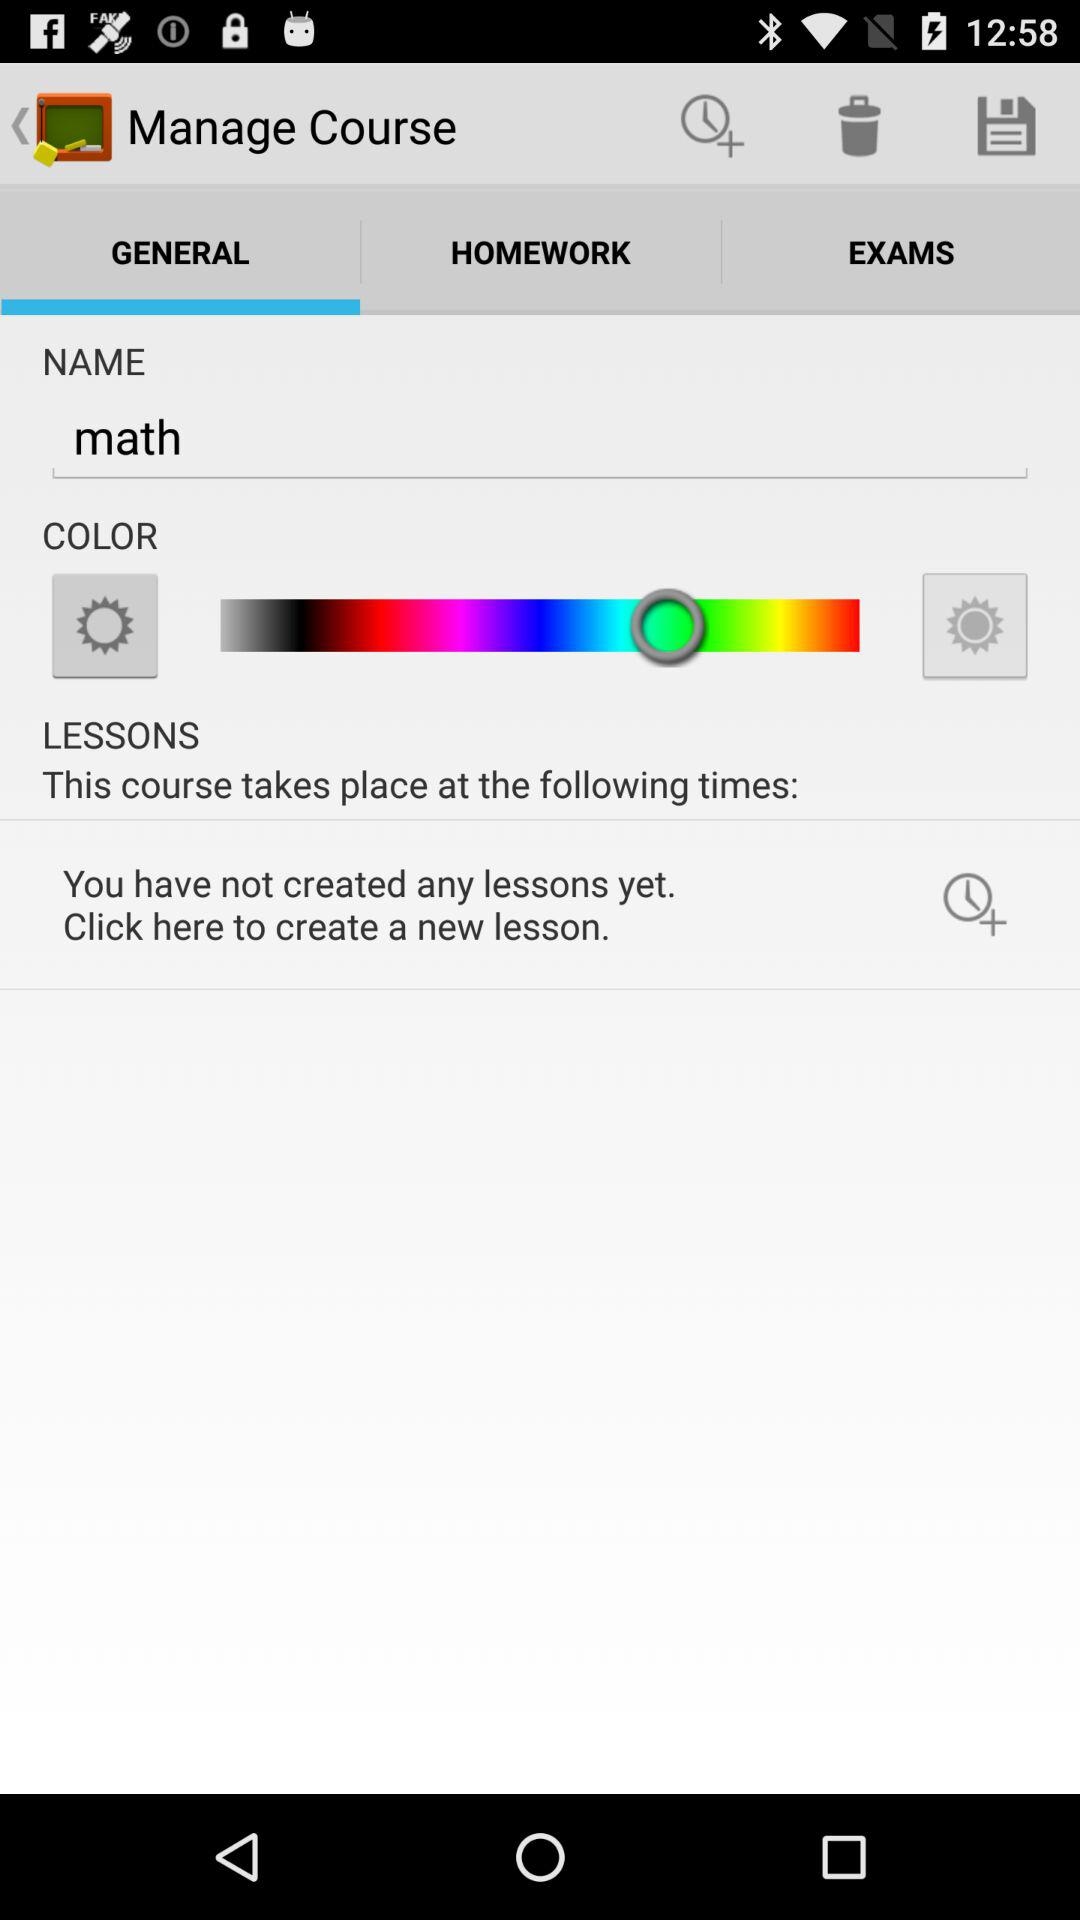How many lessons have been created?
Answer the question using a single word or phrase. 0 